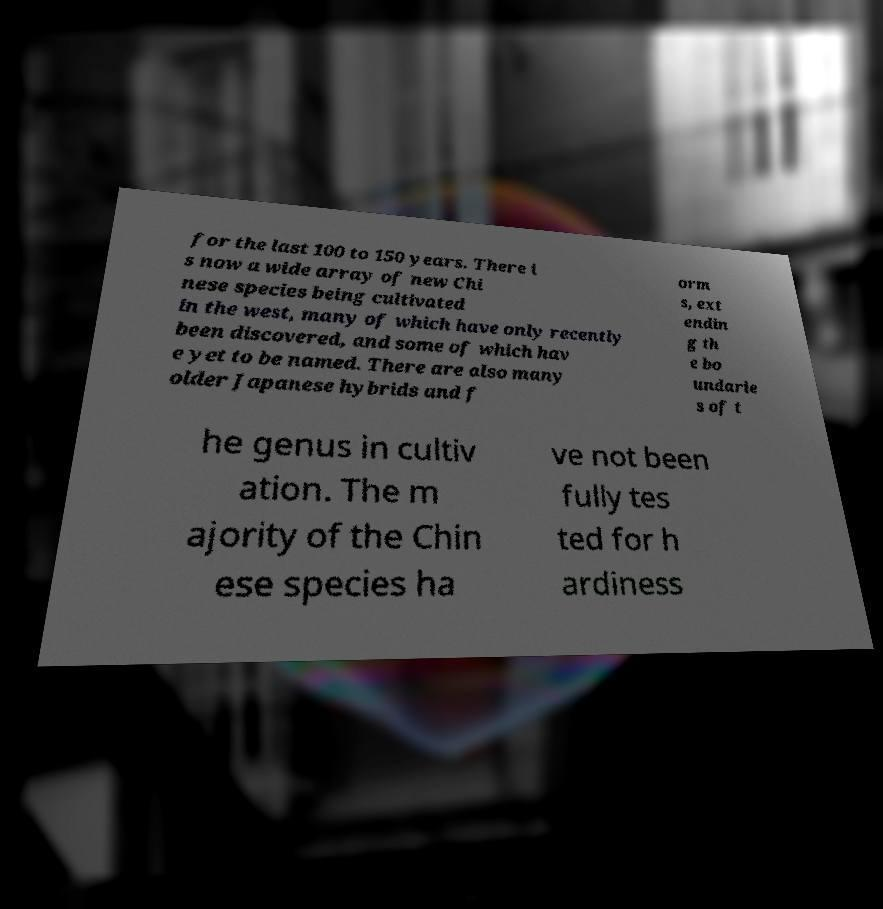Please identify and transcribe the text found in this image. for the last 100 to 150 years. There i s now a wide array of new Chi nese species being cultivated in the west, many of which have only recently been discovered, and some of which hav e yet to be named. There are also many older Japanese hybrids and f orm s, ext endin g th e bo undarie s of t he genus in cultiv ation. The m ajority of the Chin ese species ha ve not been fully tes ted for h ardiness 